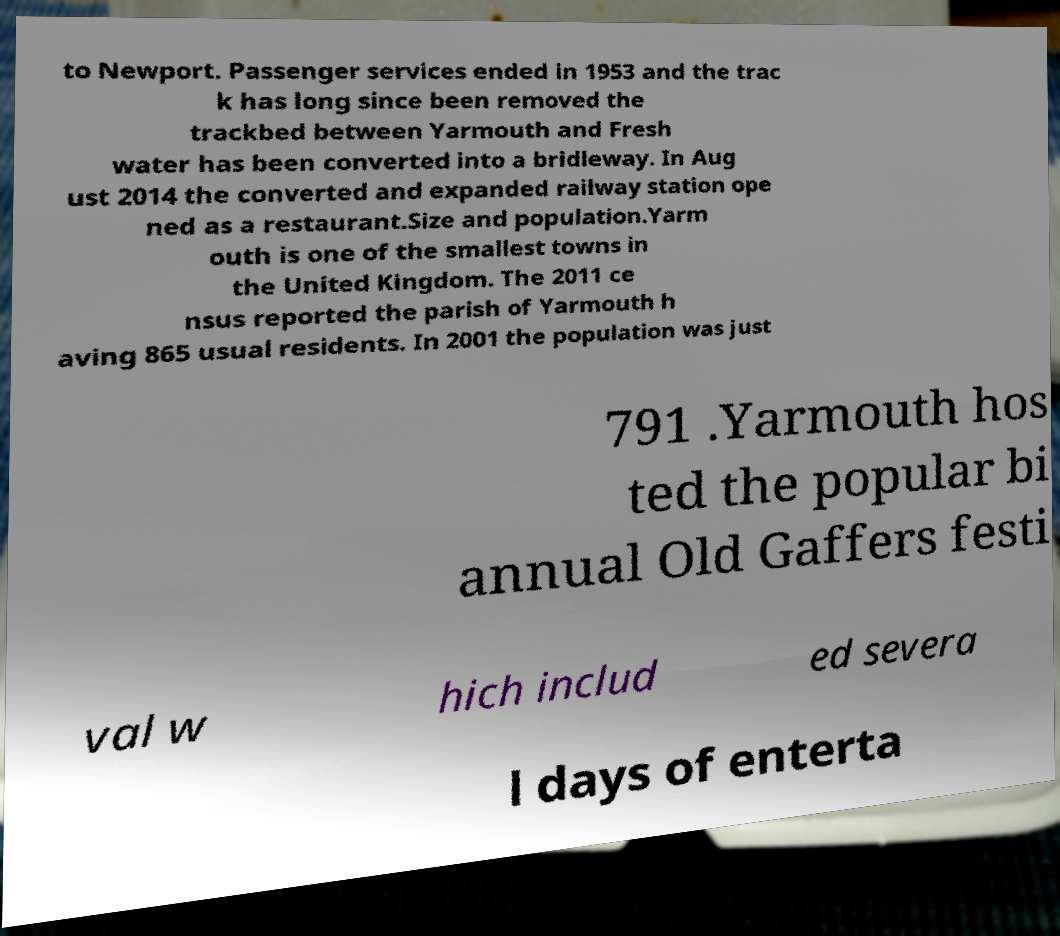Could you assist in decoding the text presented in this image and type it out clearly? to Newport. Passenger services ended in 1953 and the trac k has long since been removed the trackbed between Yarmouth and Fresh water has been converted into a bridleway. In Aug ust 2014 the converted and expanded railway station ope ned as a restaurant.Size and population.Yarm outh is one of the smallest towns in the United Kingdom. The 2011 ce nsus reported the parish of Yarmouth h aving 865 usual residents. In 2001 the population was just 791 .Yarmouth hos ted the popular bi annual Old Gaffers festi val w hich includ ed severa l days of enterta 